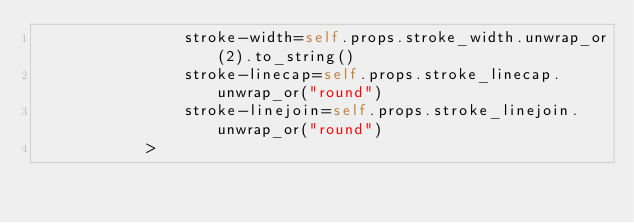Convert code to text. <code><loc_0><loc_0><loc_500><loc_500><_Rust_>                stroke-width=self.props.stroke_width.unwrap_or(2).to_string()
                stroke-linecap=self.props.stroke_linecap.unwrap_or("round")
                stroke-linejoin=self.props.stroke_linejoin.unwrap_or("round")
            ></code> 